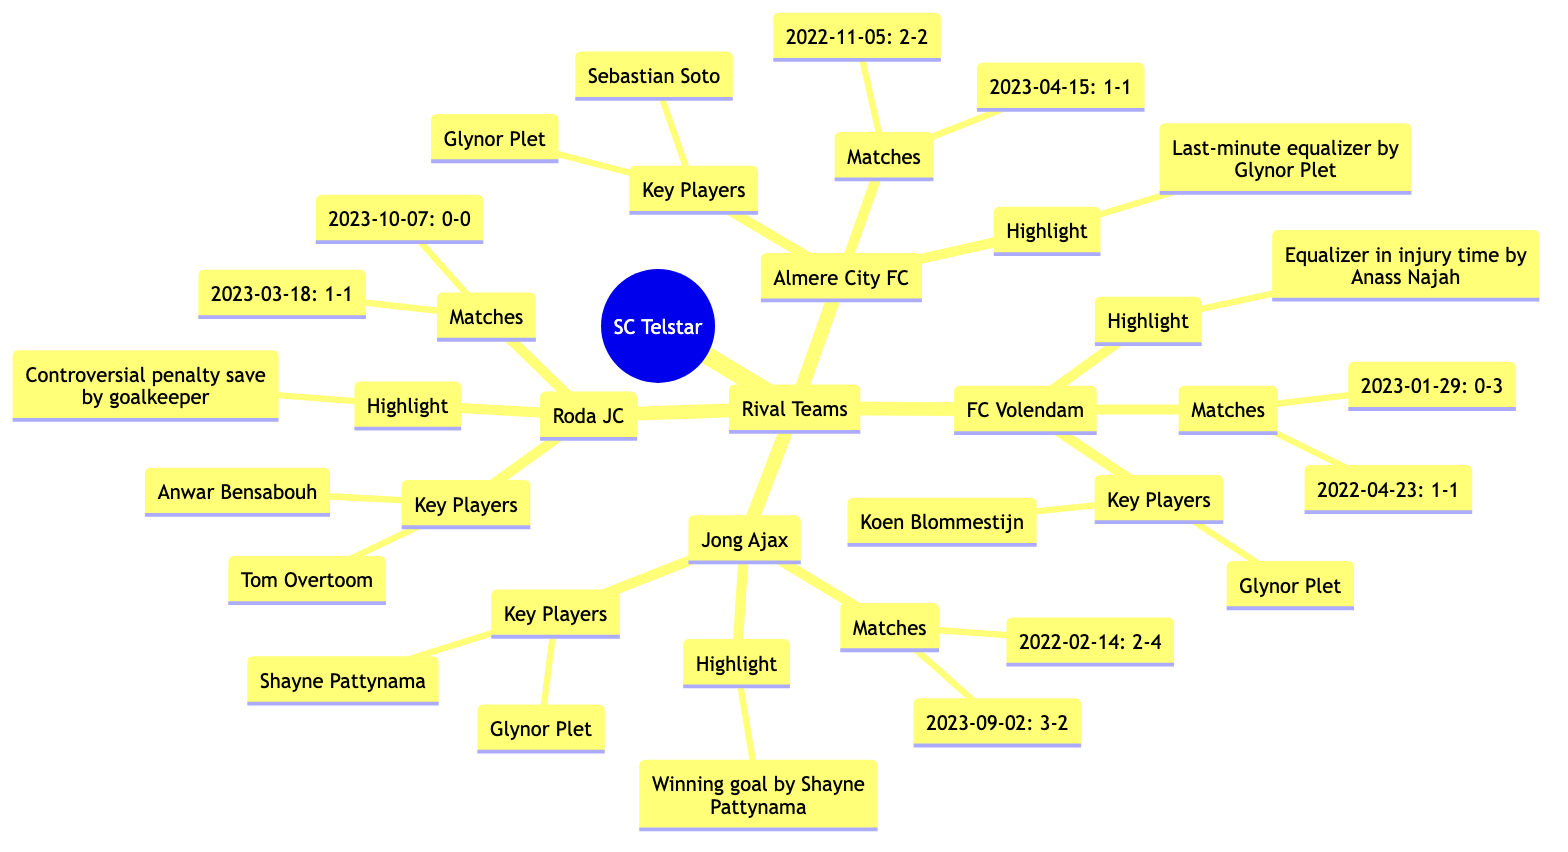What teams have played against SC Telstar? The diagram lists four teams that have played against SC Telstar under the "Rival Teams" section: Almere City FC, FC Volendam, Jong Ajax, and Roda JC.
Answer: Almere City FC, FC Volendam, Jong Ajax, Roda JC How many matches were played against FC Volendam? The diagram shows two matches listed under FC Volendam: one on 2023-01-29 with a score of 0-3 and another on 2022-04-23 with a score of 1-1. Therefore, there are two matches.
Answer: 2 Who scored the last-minute equalizer against Almere City FC? The highlight moment for Almere City FC states that the last-minute equalizer was scored by Glynor Plet.
Answer: Glynor Plet What was the result of the match played on 2022-11-05 against Almere City FC? The diagram has the historical match result for the game on 2022-11-05 against Almere City FC, which is represented as a 2-2 draw.
Answer: 2-2 Which key player is common between SC Telstar's matches against Almere City FC and Jong Ajax? For both Almere City FC and Jong Ajax, Glynor Plet is listed as a key player. Therefore, he is the common key player in those matches.
Answer: Glynor Plet What was the highlight moment in the match on 2023-03-18 against Roda JC? The highlight for the match on 2023-03-18 against Roda JC reveals a controversial penalty save made by the goalkeeper.
Answer: Controversial penalty save by goalkeeper Which team did SC Telstar defeat in their match on 2023-09-02? The historical match result for the game on 2023-09-02 shows that SC Telstar won against Jong Ajax with a score of 3-2.
Answer: Jong Ajax How many rival teams are listed in the diagram? The diagram explicitly lists four rival teams under the SC Telstar node. These teams are Almere City FC, FC Volendam, Jong Ajax, and Roda JC. Thus, there are four rival teams.
Answer: 4 